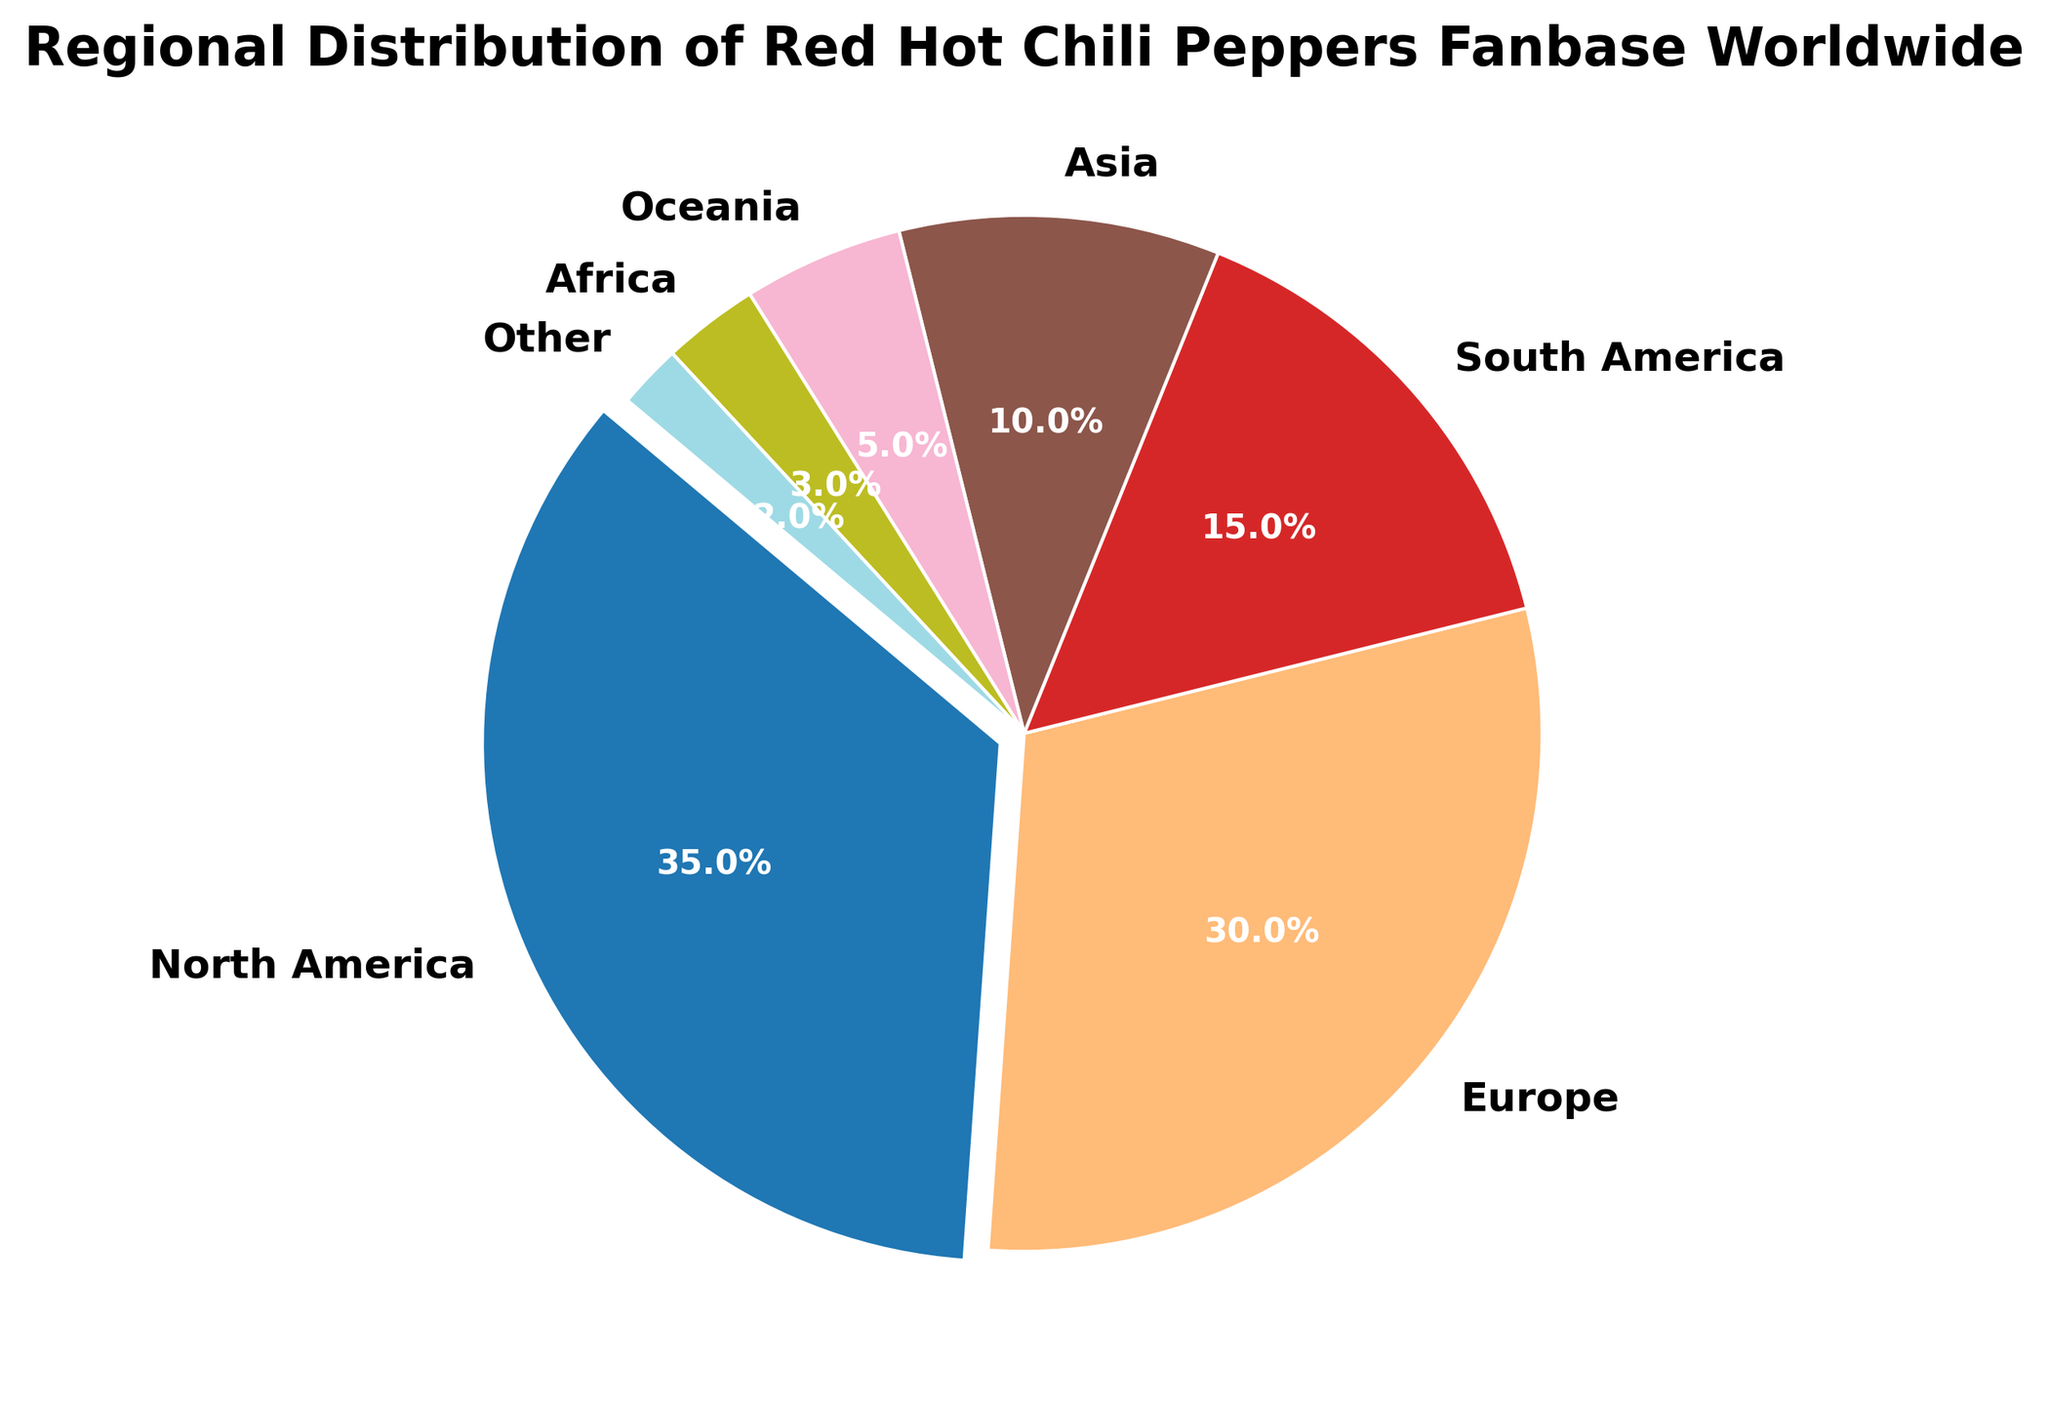What percentage of the Red Hot Chili Peppers fanbase is in North America? To find the percentage of the fanbase in North America, simply look at the segment in the pie chart labeled 'North America'. It shows that 35% of the fanbase is from this region.
Answer: 35% Which region has the smallest fanbase percentage, and what is that percentage? To determine the smallest fanbase percentage, identify the region with the smallest segment in the pie chart. The segment labeled 'Other' represents the smallest fanbase with 2%.
Answer: Other, 2% What is the combined fanbase percentage of Asia and Oceania? To find the combined percentage, sum the fanbase percentages for Asia (10%) and Oceania (5%). So, 10% + 5% = 15%.
Answer: 15% Is the fanbase in Europe greater than in South America, and by how much? To compare the fanbases, subtract the percentage of South America (15%) from the percentage of Europe (30%). 30% - 15% = 15%.
Answer: Yes, by 15% How much larger is the fanbase in North America compared to Africa? To find the difference, subtract the percentage of Africa (3%) from the percentage of North America (35%). 35% - 3% = 32%.
Answer: 32% Which regions have a fanbase percentage less than 10%? Identify the regions in the pie chart where the fanbase percentage is shown as less than 10%. Africa (3%) and Other (2%) are the regions with a fanbase percentage less than 10%.
Answer: Africa, Other What percentage of the fanbase is in the top three largest regions combined? To find the combined percentage of the top three regions, sum the percentages of North America (35%), Europe (30%), and South America (15%). 35% + 30% + 15% = 80%.
Answer: 80% What color represents Europe in the pie chart? Look for the segment labeled 'Europe' in the pie chart and identify its corresponding color by visual inspection.
Answer: [Visual inspection needed for specific color] Which two regions together account for 20% of the fanbase? Sum the fanbase percentages of each pair of regions until finding one that adds up to 20%. Asia (10%) and Oceania (5%) together add up to 15%, but adding Africa (3%) makes it 18%, and we need Oceania (5%) and Other (2%) which together sum up 20%.
Answer: Oceania, Other 